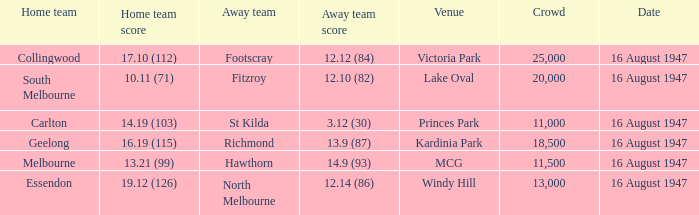What venue had footscray play at it? Victoria Park. 